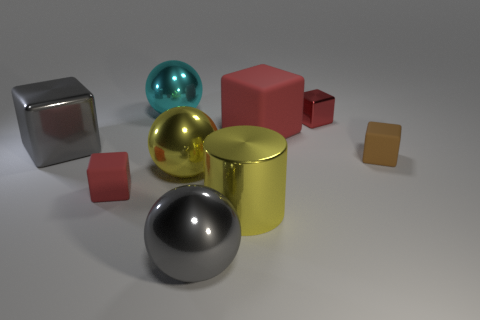Subtract all purple cylinders. How many red blocks are left? 3 Subtract all gray spheres. How many spheres are left? 2 Subtract 1 balls. How many balls are left? 2 Subtract all brown cubes. How many cubes are left? 4 Subtract all yellow cubes. Subtract all gray cylinders. How many cubes are left? 5 Subtract all spheres. How many objects are left? 6 Add 7 small brown blocks. How many small brown blocks exist? 8 Subtract 0 gray cylinders. How many objects are left? 9 Subtract all large gray balls. Subtract all gray rubber objects. How many objects are left? 8 Add 2 red rubber objects. How many red rubber objects are left? 4 